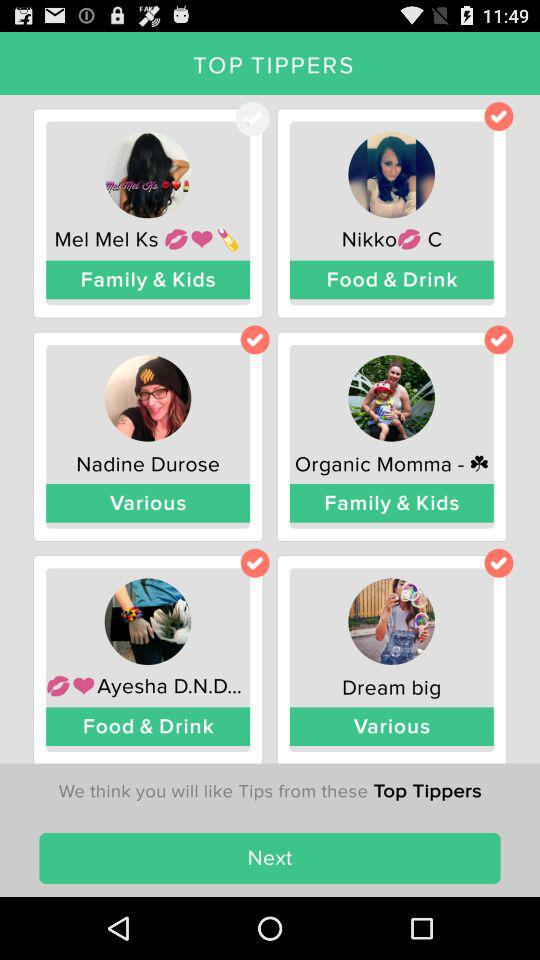How old is "Mel Mel Ks"?
When the provided information is insufficient, respond with <no answer>. <no answer> 